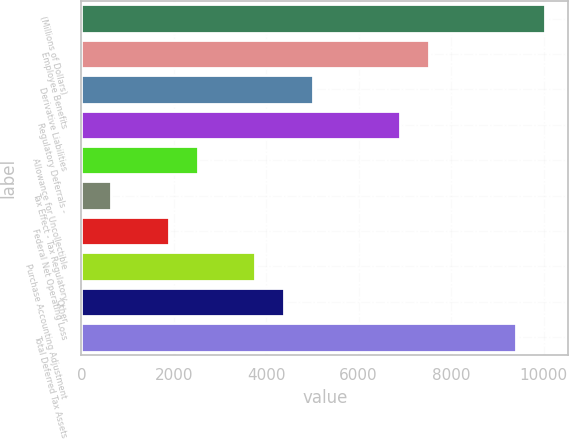<chart> <loc_0><loc_0><loc_500><loc_500><bar_chart><fcel>(Millions of Dollars)<fcel>Employee Benefits<fcel>Derivative Liabilities<fcel>Regulatory Deferrals -<fcel>Allowance for Uncollectible<fcel>Tax Effect - Tax Regulatory<fcel>Federal Net Operating Loss<fcel>Purchase Accounting Adjustment<fcel>Other<fcel>Total Deferred Tax Assets<nl><fcel>10038.1<fcel>7529.82<fcel>5021.58<fcel>6902.76<fcel>2513.34<fcel>632.16<fcel>1886.28<fcel>3767.46<fcel>4394.52<fcel>9411<nl></chart> 